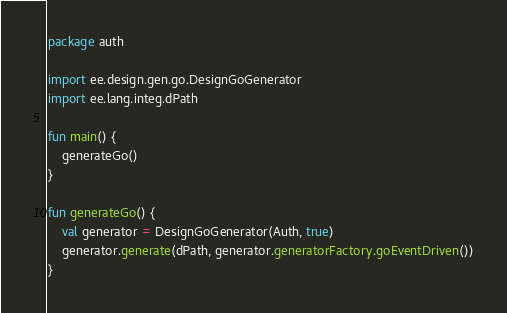<code> <loc_0><loc_0><loc_500><loc_500><_Kotlin_>package auth

import ee.design.gen.go.DesignGoGenerator
import ee.lang.integ.dPath

fun main() {
    generateGo()
}

fun generateGo() {
    val generator = DesignGoGenerator(Auth, true)
    generator.generate(dPath, generator.generatorFactory.goEventDriven())
}

</code> 